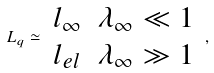Convert formula to latex. <formula><loc_0><loc_0><loc_500><loc_500>L _ { q } \simeq \begin{array} { c c } l _ { \infty } & \lambda _ { \infty } \ll 1 \\ l _ { e l } & \lambda _ { \infty } \gg 1 \end{array} \, ,</formula> 